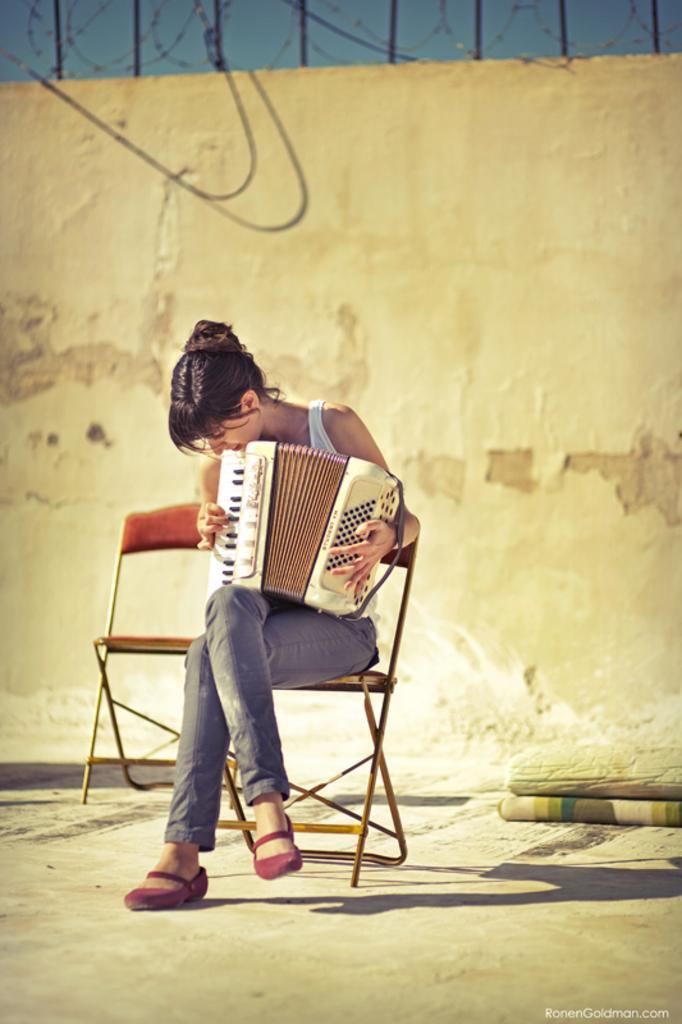Can you describe this image briefly? In the center of the image a lady is sitting on a chair and playing accordion. In the background of the image we can see the wall. At the top of the image we can see the grilles. In the middle of the image we can see the chairs and some objects. At the bottom of the image we can the floor. In the bottom right corner we can see some text. 